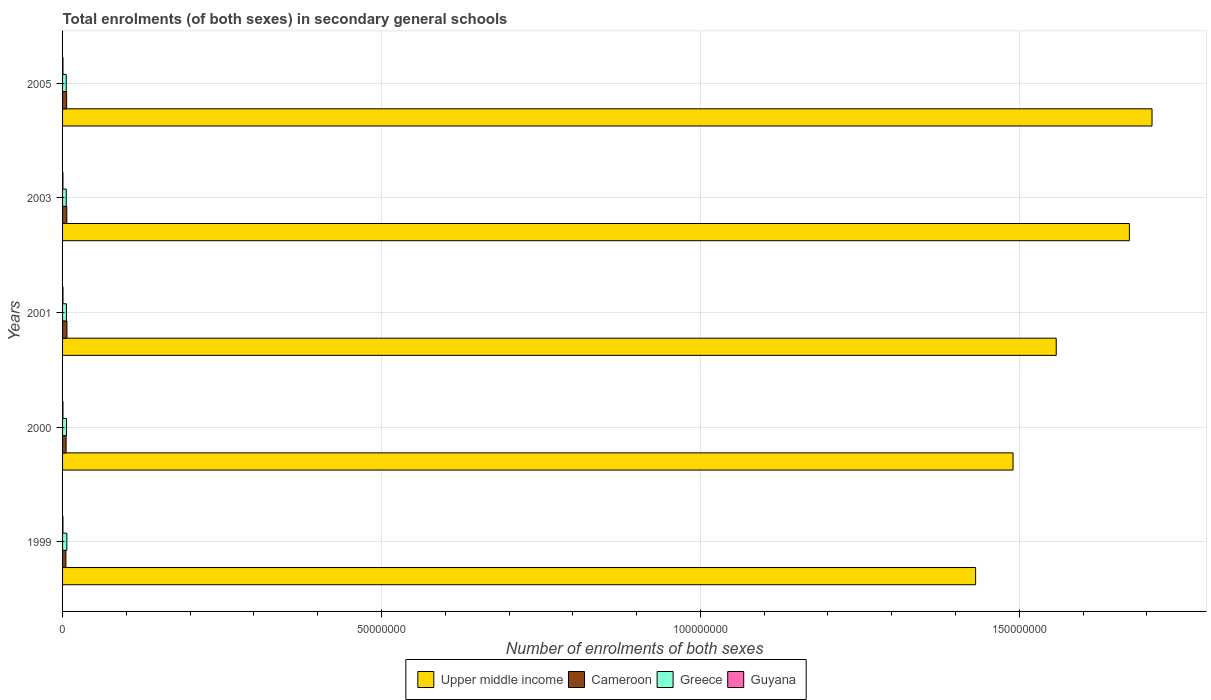How many groups of bars are there?
Keep it short and to the point. 5. Are the number of bars per tick equal to the number of legend labels?
Your response must be concise. Yes. In how many cases, is the number of bars for a given year not equal to the number of legend labels?
Keep it short and to the point. 0. What is the number of enrolments in secondary schools in Guyana in 1999?
Offer a terse response. 5.80e+04. Across all years, what is the maximum number of enrolments in secondary schools in Upper middle income?
Give a very brief answer. 1.71e+08. Across all years, what is the minimum number of enrolments in secondary schools in Guyana?
Your answer should be very brief. 5.80e+04. In which year was the number of enrolments in secondary schools in Cameroon maximum?
Offer a terse response. 2001. In which year was the number of enrolments in secondary schools in Cameroon minimum?
Your answer should be very brief. 1999. What is the total number of enrolments in secondary schools in Guyana in the graph?
Keep it short and to the point. 3.09e+05. What is the difference between the number of enrolments in secondary schools in Upper middle income in 2000 and that in 2001?
Provide a short and direct response. -6.77e+06. What is the difference between the number of enrolments in secondary schools in Greece in 2000 and the number of enrolments in secondary schools in Guyana in 2003?
Ensure brevity in your answer.  5.60e+05. What is the average number of enrolments in secondary schools in Upper middle income per year?
Ensure brevity in your answer.  1.57e+08. In the year 2000, what is the difference between the number of enrolments in secondary schools in Greece and number of enrolments in secondary schools in Upper middle income?
Keep it short and to the point. -1.48e+08. What is the ratio of the number of enrolments in secondary schools in Greece in 2000 to that in 2005?
Your response must be concise. 1.07. Is the difference between the number of enrolments in secondary schools in Greece in 2000 and 2001 greater than the difference between the number of enrolments in secondary schools in Upper middle income in 2000 and 2001?
Offer a very short reply. Yes. What is the difference between the highest and the second highest number of enrolments in secondary schools in Greece?
Your answer should be compact. 5.04e+04. What is the difference between the highest and the lowest number of enrolments in secondary schools in Cameroon?
Provide a succinct answer. 1.64e+05. In how many years, is the number of enrolments in secondary schools in Greece greater than the average number of enrolments in secondary schools in Greece taken over all years?
Offer a terse response. 2. Is the sum of the number of enrolments in secondary schools in Greece in 2001 and 2003 greater than the maximum number of enrolments in secondary schools in Cameroon across all years?
Provide a short and direct response. Yes. Is it the case that in every year, the sum of the number of enrolments in secondary schools in Greece and number of enrolments in secondary schools in Upper middle income is greater than the sum of number of enrolments in secondary schools in Cameroon and number of enrolments in secondary schools in Guyana?
Give a very brief answer. No. What does the 2nd bar from the top in 1999 represents?
Your answer should be compact. Greece. What does the 4th bar from the bottom in 2000 represents?
Ensure brevity in your answer.  Guyana. Is it the case that in every year, the sum of the number of enrolments in secondary schools in Upper middle income and number of enrolments in secondary schools in Cameroon is greater than the number of enrolments in secondary schools in Greece?
Offer a very short reply. Yes. How many years are there in the graph?
Make the answer very short. 5. Are the values on the major ticks of X-axis written in scientific E-notation?
Offer a terse response. No. Does the graph contain any zero values?
Offer a terse response. No. Where does the legend appear in the graph?
Your answer should be very brief. Bottom center. How many legend labels are there?
Offer a terse response. 4. What is the title of the graph?
Keep it short and to the point. Total enrolments (of both sexes) in secondary general schools. Does "Bahamas" appear as one of the legend labels in the graph?
Your response must be concise. No. What is the label or title of the X-axis?
Your answer should be very brief. Number of enrolments of both sexes. What is the label or title of the Y-axis?
Give a very brief answer. Years. What is the Number of enrolments of both sexes of Upper middle income in 1999?
Give a very brief answer. 1.43e+08. What is the Number of enrolments of both sexes in Cameroon in 1999?
Provide a succinct answer. 5.21e+05. What is the Number of enrolments of both sexes in Greece in 1999?
Offer a terse response. 6.70e+05. What is the Number of enrolments of both sexes in Guyana in 1999?
Your response must be concise. 5.80e+04. What is the Number of enrolments of both sexes of Upper middle income in 2000?
Your answer should be very brief. 1.49e+08. What is the Number of enrolments of both sexes of Cameroon in 2000?
Make the answer very short. 5.55e+05. What is the Number of enrolments of both sexes of Greece in 2000?
Provide a succinct answer. 6.19e+05. What is the Number of enrolments of both sexes of Guyana in 2000?
Offer a very short reply. 6.17e+04. What is the Number of enrolments of both sexes of Upper middle income in 2001?
Make the answer very short. 1.56e+08. What is the Number of enrolments of both sexes in Cameroon in 2001?
Provide a succinct answer. 6.85e+05. What is the Number of enrolments of both sexes of Greece in 2001?
Offer a very short reply. 6.09e+05. What is the Number of enrolments of both sexes of Guyana in 2001?
Offer a terse response. 6.58e+04. What is the Number of enrolments of both sexes in Upper middle income in 2003?
Give a very brief answer. 1.67e+08. What is the Number of enrolments of both sexes of Cameroon in 2003?
Your answer should be compact. 6.69e+05. What is the Number of enrolments of both sexes of Greece in 2003?
Offer a terse response. 5.80e+05. What is the Number of enrolments of both sexes of Guyana in 2003?
Give a very brief answer. 5.94e+04. What is the Number of enrolments of both sexes of Upper middle income in 2005?
Your answer should be compact. 1.71e+08. What is the Number of enrolments of both sexes of Cameroon in 2005?
Give a very brief answer. 6.40e+05. What is the Number of enrolments of both sexes of Greece in 2005?
Your response must be concise. 5.78e+05. What is the Number of enrolments of both sexes of Guyana in 2005?
Provide a short and direct response. 6.38e+04. Across all years, what is the maximum Number of enrolments of both sexes of Upper middle income?
Make the answer very short. 1.71e+08. Across all years, what is the maximum Number of enrolments of both sexes in Cameroon?
Provide a succinct answer. 6.85e+05. Across all years, what is the maximum Number of enrolments of both sexes of Greece?
Your answer should be very brief. 6.70e+05. Across all years, what is the maximum Number of enrolments of both sexes in Guyana?
Give a very brief answer. 6.58e+04. Across all years, what is the minimum Number of enrolments of both sexes in Upper middle income?
Offer a terse response. 1.43e+08. Across all years, what is the minimum Number of enrolments of both sexes in Cameroon?
Offer a terse response. 5.21e+05. Across all years, what is the minimum Number of enrolments of both sexes in Greece?
Provide a succinct answer. 5.78e+05. Across all years, what is the minimum Number of enrolments of both sexes of Guyana?
Keep it short and to the point. 5.80e+04. What is the total Number of enrolments of both sexes in Upper middle income in the graph?
Ensure brevity in your answer.  7.86e+08. What is the total Number of enrolments of both sexes of Cameroon in the graph?
Ensure brevity in your answer.  3.07e+06. What is the total Number of enrolments of both sexes of Greece in the graph?
Ensure brevity in your answer.  3.06e+06. What is the total Number of enrolments of both sexes in Guyana in the graph?
Your response must be concise. 3.09e+05. What is the difference between the Number of enrolments of both sexes of Upper middle income in 1999 and that in 2000?
Provide a short and direct response. -5.87e+06. What is the difference between the Number of enrolments of both sexes in Cameroon in 1999 and that in 2000?
Offer a very short reply. -3.42e+04. What is the difference between the Number of enrolments of both sexes in Greece in 1999 and that in 2000?
Your response must be concise. 5.04e+04. What is the difference between the Number of enrolments of both sexes of Guyana in 1999 and that in 2000?
Provide a succinct answer. -3670. What is the difference between the Number of enrolments of both sexes of Upper middle income in 1999 and that in 2001?
Provide a short and direct response. -1.26e+07. What is the difference between the Number of enrolments of both sexes in Cameroon in 1999 and that in 2001?
Provide a succinct answer. -1.64e+05. What is the difference between the Number of enrolments of both sexes of Greece in 1999 and that in 2001?
Provide a succinct answer. 6.06e+04. What is the difference between the Number of enrolments of both sexes of Guyana in 1999 and that in 2001?
Provide a succinct answer. -7793. What is the difference between the Number of enrolments of both sexes in Upper middle income in 1999 and that in 2003?
Offer a very short reply. -2.41e+07. What is the difference between the Number of enrolments of both sexes of Cameroon in 1999 and that in 2003?
Offer a terse response. -1.48e+05. What is the difference between the Number of enrolments of both sexes in Greece in 1999 and that in 2003?
Ensure brevity in your answer.  8.98e+04. What is the difference between the Number of enrolments of both sexes in Guyana in 1999 and that in 2003?
Your answer should be very brief. -1340. What is the difference between the Number of enrolments of both sexes in Upper middle income in 1999 and that in 2005?
Your answer should be compact. -2.77e+07. What is the difference between the Number of enrolments of both sexes of Cameroon in 1999 and that in 2005?
Offer a very short reply. -1.19e+05. What is the difference between the Number of enrolments of both sexes of Greece in 1999 and that in 2005?
Offer a terse response. 9.13e+04. What is the difference between the Number of enrolments of both sexes of Guyana in 1999 and that in 2005?
Offer a terse response. -5778. What is the difference between the Number of enrolments of both sexes in Upper middle income in 2000 and that in 2001?
Offer a terse response. -6.77e+06. What is the difference between the Number of enrolments of both sexes in Cameroon in 2000 and that in 2001?
Ensure brevity in your answer.  -1.30e+05. What is the difference between the Number of enrolments of both sexes in Greece in 2000 and that in 2001?
Keep it short and to the point. 1.02e+04. What is the difference between the Number of enrolments of both sexes of Guyana in 2000 and that in 2001?
Your answer should be compact. -4123. What is the difference between the Number of enrolments of both sexes in Upper middle income in 2000 and that in 2003?
Your answer should be very brief. -1.82e+07. What is the difference between the Number of enrolments of both sexes of Cameroon in 2000 and that in 2003?
Keep it short and to the point. -1.14e+05. What is the difference between the Number of enrolments of both sexes in Greece in 2000 and that in 2003?
Your response must be concise. 3.93e+04. What is the difference between the Number of enrolments of both sexes in Guyana in 2000 and that in 2003?
Provide a succinct answer. 2330. What is the difference between the Number of enrolments of both sexes in Upper middle income in 2000 and that in 2005?
Ensure brevity in your answer.  -2.18e+07. What is the difference between the Number of enrolments of both sexes of Cameroon in 2000 and that in 2005?
Offer a terse response. -8.53e+04. What is the difference between the Number of enrolments of both sexes in Greece in 2000 and that in 2005?
Provide a short and direct response. 4.09e+04. What is the difference between the Number of enrolments of both sexes of Guyana in 2000 and that in 2005?
Give a very brief answer. -2108. What is the difference between the Number of enrolments of both sexes in Upper middle income in 2001 and that in 2003?
Ensure brevity in your answer.  -1.15e+07. What is the difference between the Number of enrolments of both sexes of Cameroon in 2001 and that in 2003?
Your answer should be compact. 1.55e+04. What is the difference between the Number of enrolments of both sexes of Greece in 2001 and that in 2003?
Your response must be concise. 2.92e+04. What is the difference between the Number of enrolments of both sexes of Guyana in 2001 and that in 2003?
Your response must be concise. 6453. What is the difference between the Number of enrolments of both sexes of Upper middle income in 2001 and that in 2005?
Offer a terse response. -1.50e+07. What is the difference between the Number of enrolments of both sexes of Cameroon in 2001 and that in 2005?
Keep it short and to the point. 4.45e+04. What is the difference between the Number of enrolments of both sexes of Greece in 2001 and that in 2005?
Your answer should be compact. 3.07e+04. What is the difference between the Number of enrolments of both sexes in Guyana in 2001 and that in 2005?
Offer a very short reply. 2015. What is the difference between the Number of enrolments of both sexes of Upper middle income in 2003 and that in 2005?
Give a very brief answer. -3.55e+06. What is the difference between the Number of enrolments of both sexes of Cameroon in 2003 and that in 2005?
Offer a very short reply. 2.90e+04. What is the difference between the Number of enrolments of both sexes of Greece in 2003 and that in 2005?
Keep it short and to the point. 1548. What is the difference between the Number of enrolments of both sexes of Guyana in 2003 and that in 2005?
Offer a very short reply. -4438. What is the difference between the Number of enrolments of both sexes in Upper middle income in 1999 and the Number of enrolments of both sexes in Cameroon in 2000?
Offer a terse response. 1.43e+08. What is the difference between the Number of enrolments of both sexes in Upper middle income in 1999 and the Number of enrolments of both sexes in Greece in 2000?
Offer a very short reply. 1.43e+08. What is the difference between the Number of enrolments of both sexes in Upper middle income in 1999 and the Number of enrolments of both sexes in Guyana in 2000?
Provide a succinct answer. 1.43e+08. What is the difference between the Number of enrolments of both sexes of Cameroon in 1999 and the Number of enrolments of both sexes of Greece in 2000?
Make the answer very short. -9.84e+04. What is the difference between the Number of enrolments of both sexes of Cameroon in 1999 and the Number of enrolments of both sexes of Guyana in 2000?
Your answer should be compact. 4.59e+05. What is the difference between the Number of enrolments of both sexes in Greece in 1999 and the Number of enrolments of both sexes in Guyana in 2000?
Keep it short and to the point. 6.08e+05. What is the difference between the Number of enrolments of both sexes in Upper middle income in 1999 and the Number of enrolments of both sexes in Cameroon in 2001?
Offer a very short reply. 1.42e+08. What is the difference between the Number of enrolments of both sexes of Upper middle income in 1999 and the Number of enrolments of both sexes of Greece in 2001?
Your answer should be very brief. 1.43e+08. What is the difference between the Number of enrolments of both sexes in Upper middle income in 1999 and the Number of enrolments of both sexes in Guyana in 2001?
Offer a terse response. 1.43e+08. What is the difference between the Number of enrolments of both sexes in Cameroon in 1999 and the Number of enrolments of both sexes in Greece in 2001?
Your answer should be very brief. -8.83e+04. What is the difference between the Number of enrolments of both sexes in Cameroon in 1999 and the Number of enrolments of both sexes in Guyana in 2001?
Keep it short and to the point. 4.55e+05. What is the difference between the Number of enrolments of both sexes of Greece in 1999 and the Number of enrolments of both sexes of Guyana in 2001?
Give a very brief answer. 6.04e+05. What is the difference between the Number of enrolments of both sexes in Upper middle income in 1999 and the Number of enrolments of both sexes in Cameroon in 2003?
Give a very brief answer. 1.42e+08. What is the difference between the Number of enrolments of both sexes of Upper middle income in 1999 and the Number of enrolments of both sexes of Greece in 2003?
Offer a terse response. 1.43e+08. What is the difference between the Number of enrolments of both sexes in Upper middle income in 1999 and the Number of enrolments of both sexes in Guyana in 2003?
Your answer should be very brief. 1.43e+08. What is the difference between the Number of enrolments of both sexes in Cameroon in 1999 and the Number of enrolments of both sexes in Greece in 2003?
Offer a terse response. -5.91e+04. What is the difference between the Number of enrolments of both sexes in Cameroon in 1999 and the Number of enrolments of both sexes in Guyana in 2003?
Offer a terse response. 4.61e+05. What is the difference between the Number of enrolments of both sexes in Greece in 1999 and the Number of enrolments of both sexes in Guyana in 2003?
Your answer should be compact. 6.10e+05. What is the difference between the Number of enrolments of both sexes in Upper middle income in 1999 and the Number of enrolments of both sexes in Cameroon in 2005?
Offer a terse response. 1.43e+08. What is the difference between the Number of enrolments of both sexes in Upper middle income in 1999 and the Number of enrolments of both sexes in Greece in 2005?
Provide a short and direct response. 1.43e+08. What is the difference between the Number of enrolments of both sexes of Upper middle income in 1999 and the Number of enrolments of both sexes of Guyana in 2005?
Ensure brevity in your answer.  1.43e+08. What is the difference between the Number of enrolments of both sexes of Cameroon in 1999 and the Number of enrolments of both sexes of Greece in 2005?
Your answer should be compact. -5.75e+04. What is the difference between the Number of enrolments of both sexes in Cameroon in 1999 and the Number of enrolments of both sexes in Guyana in 2005?
Your response must be concise. 4.57e+05. What is the difference between the Number of enrolments of both sexes of Greece in 1999 and the Number of enrolments of both sexes of Guyana in 2005?
Offer a terse response. 6.06e+05. What is the difference between the Number of enrolments of both sexes of Upper middle income in 2000 and the Number of enrolments of both sexes of Cameroon in 2001?
Provide a short and direct response. 1.48e+08. What is the difference between the Number of enrolments of both sexes in Upper middle income in 2000 and the Number of enrolments of both sexes in Greece in 2001?
Ensure brevity in your answer.  1.48e+08. What is the difference between the Number of enrolments of both sexes in Upper middle income in 2000 and the Number of enrolments of both sexes in Guyana in 2001?
Provide a succinct answer. 1.49e+08. What is the difference between the Number of enrolments of both sexes of Cameroon in 2000 and the Number of enrolments of both sexes of Greece in 2001?
Provide a succinct answer. -5.41e+04. What is the difference between the Number of enrolments of both sexes of Cameroon in 2000 and the Number of enrolments of both sexes of Guyana in 2001?
Provide a short and direct response. 4.89e+05. What is the difference between the Number of enrolments of both sexes of Greece in 2000 and the Number of enrolments of both sexes of Guyana in 2001?
Offer a terse response. 5.53e+05. What is the difference between the Number of enrolments of both sexes in Upper middle income in 2000 and the Number of enrolments of both sexes in Cameroon in 2003?
Your answer should be very brief. 1.48e+08. What is the difference between the Number of enrolments of both sexes of Upper middle income in 2000 and the Number of enrolments of both sexes of Greece in 2003?
Your answer should be compact. 1.48e+08. What is the difference between the Number of enrolments of both sexes in Upper middle income in 2000 and the Number of enrolments of both sexes in Guyana in 2003?
Keep it short and to the point. 1.49e+08. What is the difference between the Number of enrolments of both sexes of Cameroon in 2000 and the Number of enrolments of both sexes of Greece in 2003?
Ensure brevity in your answer.  -2.49e+04. What is the difference between the Number of enrolments of both sexes of Cameroon in 2000 and the Number of enrolments of both sexes of Guyana in 2003?
Your response must be concise. 4.95e+05. What is the difference between the Number of enrolments of both sexes in Greece in 2000 and the Number of enrolments of both sexes in Guyana in 2003?
Your answer should be very brief. 5.60e+05. What is the difference between the Number of enrolments of both sexes in Upper middle income in 2000 and the Number of enrolments of both sexes in Cameroon in 2005?
Provide a short and direct response. 1.48e+08. What is the difference between the Number of enrolments of both sexes of Upper middle income in 2000 and the Number of enrolments of both sexes of Greece in 2005?
Offer a very short reply. 1.48e+08. What is the difference between the Number of enrolments of both sexes in Upper middle income in 2000 and the Number of enrolments of both sexes in Guyana in 2005?
Make the answer very short. 1.49e+08. What is the difference between the Number of enrolments of both sexes in Cameroon in 2000 and the Number of enrolments of both sexes in Greece in 2005?
Provide a succinct answer. -2.34e+04. What is the difference between the Number of enrolments of both sexes of Cameroon in 2000 and the Number of enrolments of both sexes of Guyana in 2005?
Ensure brevity in your answer.  4.91e+05. What is the difference between the Number of enrolments of both sexes of Greece in 2000 and the Number of enrolments of both sexes of Guyana in 2005?
Provide a short and direct response. 5.55e+05. What is the difference between the Number of enrolments of both sexes of Upper middle income in 2001 and the Number of enrolments of both sexes of Cameroon in 2003?
Ensure brevity in your answer.  1.55e+08. What is the difference between the Number of enrolments of both sexes in Upper middle income in 2001 and the Number of enrolments of both sexes in Greece in 2003?
Keep it short and to the point. 1.55e+08. What is the difference between the Number of enrolments of both sexes of Upper middle income in 2001 and the Number of enrolments of both sexes of Guyana in 2003?
Offer a terse response. 1.56e+08. What is the difference between the Number of enrolments of both sexes of Cameroon in 2001 and the Number of enrolments of both sexes of Greece in 2003?
Your response must be concise. 1.05e+05. What is the difference between the Number of enrolments of both sexes of Cameroon in 2001 and the Number of enrolments of both sexes of Guyana in 2003?
Offer a very short reply. 6.25e+05. What is the difference between the Number of enrolments of both sexes of Greece in 2001 and the Number of enrolments of both sexes of Guyana in 2003?
Give a very brief answer. 5.50e+05. What is the difference between the Number of enrolments of both sexes of Upper middle income in 2001 and the Number of enrolments of both sexes of Cameroon in 2005?
Provide a succinct answer. 1.55e+08. What is the difference between the Number of enrolments of both sexes in Upper middle income in 2001 and the Number of enrolments of both sexes in Greece in 2005?
Keep it short and to the point. 1.55e+08. What is the difference between the Number of enrolments of both sexes in Upper middle income in 2001 and the Number of enrolments of both sexes in Guyana in 2005?
Your answer should be compact. 1.56e+08. What is the difference between the Number of enrolments of both sexes of Cameroon in 2001 and the Number of enrolments of both sexes of Greece in 2005?
Your answer should be compact. 1.06e+05. What is the difference between the Number of enrolments of both sexes in Cameroon in 2001 and the Number of enrolments of both sexes in Guyana in 2005?
Offer a terse response. 6.21e+05. What is the difference between the Number of enrolments of both sexes in Greece in 2001 and the Number of enrolments of both sexes in Guyana in 2005?
Provide a succinct answer. 5.45e+05. What is the difference between the Number of enrolments of both sexes in Upper middle income in 2003 and the Number of enrolments of both sexes in Cameroon in 2005?
Keep it short and to the point. 1.67e+08. What is the difference between the Number of enrolments of both sexes of Upper middle income in 2003 and the Number of enrolments of both sexes of Greece in 2005?
Make the answer very short. 1.67e+08. What is the difference between the Number of enrolments of both sexes of Upper middle income in 2003 and the Number of enrolments of both sexes of Guyana in 2005?
Your answer should be compact. 1.67e+08. What is the difference between the Number of enrolments of both sexes in Cameroon in 2003 and the Number of enrolments of both sexes in Greece in 2005?
Provide a short and direct response. 9.09e+04. What is the difference between the Number of enrolments of both sexes of Cameroon in 2003 and the Number of enrolments of both sexes of Guyana in 2005?
Give a very brief answer. 6.05e+05. What is the difference between the Number of enrolments of both sexes of Greece in 2003 and the Number of enrolments of both sexes of Guyana in 2005?
Your answer should be compact. 5.16e+05. What is the average Number of enrolments of both sexes of Upper middle income per year?
Provide a short and direct response. 1.57e+08. What is the average Number of enrolments of both sexes in Cameroon per year?
Your response must be concise. 6.14e+05. What is the average Number of enrolments of both sexes in Greece per year?
Make the answer very short. 6.11e+05. What is the average Number of enrolments of both sexes in Guyana per year?
Provide a short and direct response. 6.17e+04. In the year 1999, what is the difference between the Number of enrolments of both sexes of Upper middle income and Number of enrolments of both sexes of Cameroon?
Ensure brevity in your answer.  1.43e+08. In the year 1999, what is the difference between the Number of enrolments of both sexes in Upper middle income and Number of enrolments of both sexes in Greece?
Your answer should be very brief. 1.42e+08. In the year 1999, what is the difference between the Number of enrolments of both sexes in Upper middle income and Number of enrolments of both sexes in Guyana?
Offer a terse response. 1.43e+08. In the year 1999, what is the difference between the Number of enrolments of both sexes of Cameroon and Number of enrolments of both sexes of Greece?
Your answer should be very brief. -1.49e+05. In the year 1999, what is the difference between the Number of enrolments of both sexes in Cameroon and Number of enrolments of both sexes in Guyana?
Provide a succinct answer. 4.63e+05. In the year 1999, what is the difference between the Number of enrolments of both sexes in Greece and Number of enrolments of both sexes in Guyana?
Your answer should be very brief. 6.11e+05. In the year 2000, what is the difference between the Number of enrolments of both sexes in Upper middle income and Number of enrolments of both sexes in Cameroon?
Provide a short and direct response. 1.48e+08. In the year 2000, what is the difference between the Number of enrolments of both sexes in Upper middle income and Number of enrolments of both sexes in Greece?
Provide a succinct answer. 1.48e+08. In the year 2000, what is the difference between the Number of enrolments of both sexes of Upper middle income and Number of enrolments of both sexes of Guyana?
Ensure brevity in your answer.  1.49e+08. In the year 2000, what is the difference between the Number of enrolments of both sexes in Cameroon and Number of enrolments of both sexes in Greece?
Your answer should be very brief. -6.43e+04. In the year 2000, what is the difference between the Number of enrolments of both sexes in Cameroon and Number of enrolments of both sexes in Guyana?
Offer a terse response. 4.93e+05. In the year 2000, what is the difference between the Number of enrolments of both sexes in Greece and Number of enrolments of both sexes in Guyana?
Provide a short and direct response. 5.57e+05. In the year 2001, what is the difference between the Number of enrolments of both sexes in Upper middle income and Number of enrolments of both sexes in Cameroon?
Your answer should be very brief. 1.55e+08. In the year 2001, what is the difference between the Number of enrolments of both sexes in Upper middle income and Number of enrolments of both sexes in Greece?
Provide a short and direct response. 1.55e+08. In the year 2001, what is the difference between the Number of enrolments of both sexes of Upper middle income and Number of enrolments of both sexes of Guyana?
Keep it short and to the point. 1.56e+08. In the year 2001, what is the difference between the Number of enrolments of both sexes of Cameroon and Number of enrolments of both sexes of Greece?
Keep it short and to the point. 7.57e+04. In the year 2001, what is the difference between the Number of enrolments of both sexes in Cameroon and Number of enrolments of both sexes in Guyana?
Make the answer very short. 6.19e+05. In the year 2001, what is the difference between the Number of enrolments of both sexes of Greece and Number of enrolments of both sexes of Guyana?
Give a very brief answer. 5.43e+05. In the year 2003, what is the difference between the Number of enrolments of both sexes in Upper middle income and Number of enrolments of both sexes in Cameroon?
Offer a terse response. 1.67e+08. In the year 2003, what is the difference between the Number of enrolments of both sexes in Upper middle income and Number of enrolments of both sexes in Greece?
Give a very brief answer. 1.67e+08. In the year 2003, what is the difference between the Number of enrolments of both sexes of Upper middle income and Number of enrolments of both sexes of Guyana?
Offer a very short reply. 1.67e+08. In the year 2003, what is the difference between the Number of enrolments of both sexes of Cameroon and Number of enrolments of both sexes of Greece?
Make the answer very short. 8.94e+04. In the year 2003, what is the difference between the Number of enrolments of both sexes of Cameroon and Number of enrolments of both sexes of Guyana?
Provide a short and direct response. 6.10e+05. In the year 2003, what is the difference between the Number of enrolments of both sexes of Greece and Number of enrolments of both sexes of Guyana?
Offer a very short reply. 5.20e+05. In the year 2005, what is the difference between the Number of enrolments of both sexes of Upper middle income and Number of enrolments of both sexes of Cameroon?
Offer a very short reply. 1.70e+08. In the year 2005, what is the difference between the Number of enrolments of both sexes of Upper middle income and Number of enrolments of both sexes of Greece?
Your answer should be very brief. 1.70e+08. In the year 2005, what is the difference between the Number of enrolments of both sexes of Upper middle income and Number of enrolments of both sexes of Guyana?
Your answer should be very brief. 1.71e+08. In the year 2005, what is the difference between the Number of enrolments of both sexes of Cameroon and Number of enrolments of both sexes of Greece?
Your answer should be very brief. 6.19e+04. In the year 2005, what is the difference between the Number of enrolments of both sexes in Cameroon and Number of enrolments of both sexes in Guyana?
Ensure brevity in your answer.  5.76e+05. In the year 2005, what is the difference between the Number of enrolments of both sexes of Greece and Number of enrolments of both sexes of Guyana?
Ensure brevity in your answer.  5.14e+05. What is the ratio of the Number of enrolments of both sexes in Upper middle income in 1999 to that in 2000?
Ensure brevity in your answer.  0.96. What is the ratio of the Number of enrolments of both sexes in Cameroon in 1999 to that in 2000?
Provide a short and direct response. 0.94. What is the ratio of the Number of enrolments of both sexes in Greece in 1999 to that in 2000?
Your answer should be compact. 1.08. What is the ratio of the Number of enrolments of both sexes in Guyana in 1999 to that in 2000?
Offer a very short reply. 0.94. What is the ratio of the Number of enrolments of both sexes in Upper middle income in 1999 to that in 2001?
Offer a terse response. 0.92. What is the ratio of the Number of enrolments of both sexes in Cameroon in 1999 to that in 2001?
Your response must be concise. 0.76. What is the ratio of the Number of enrolments of both sexes in Greece in 1999 to that in 2001?
Give a very brief answer. 1.1. What is the ratio of the Number of enrolments of both sexes of Guyana in 1999 to that in 2001?
Give a very brief answer. 0.88. What is the ratio of the Number of enrolments of both sexes in Upper middle income in 1999 to that in 2003?
Make the answer very short. 0.86. What is the ratio of the Number of enrolments of both sexes of Cameroon in 1999 to that in 2003?
Your answer should be compact. 0.78. What is the ratio of the Number of enrolments of both sexes of Greece in 1999 to that in 2003?
Offer a terse response. 1.15. What is the ratio of the Number of enrolments of both sexes of Guyana in 1999 to that in 2003?
Provide a short and direct response. 0.98. What is the ratio of the Number of enrolments of both sexes of Upper middle income in 1999 to that in 2005?
Ensure brevity in your answer.  0.84. What is the ratio of the Number of enrolments of both sexes in Cameroon in 1999 to that in 2005?
Provide a short and direct response. 0.81. What is the ratio of the Number of enrolments of both sexes in Greece in 1999 to that in 2005?
Give a very brief answer. 1.16. What is the ratio of the Number of enrolments of both sexes of Guyana in 1999 to that in 2005?
Provide a succinct answer. 0.91. What is the ratio of the Number of enrolments of both sexes in Upper middle income in 2000 to that in 2001?
Keep it short and to the point. 0.96. What is the ratio of the Number of enrolments of both sexes in Cameroon in 2000 to that in 2001?
Your answer should be very brief. 0.81. What is the ratio of the Number of enrolments of both sexes of Greece in 2000 to that in 2001?
Offer a terse response. 1.02. What is the ratio of the Number of enrolments of both sexes in Guyana in 2000 to that in 2001?
Ensure brevity in your answer.  0.94. What is the ratio of the Number of enrolments of both sexes in Upper middle income in 2000 to that in 2003?
Keep it short and to the point. 0.89. What is the ratio of the Number of enrolments of both sexes of Cameroon in 2000 to that in 2003?
Offer a very short reply. 0.83. What is the ratio of the Number of enrolments of both sexes of Greece in 2000 to that in 2003?
Provide a short and direct response. 1.07. What is the ratio of the Number of enrolments of both sexes of Guyana in 2000 to that in 2003?
Make the answer very short. 1.04. What is the ratio of the Number of enrolments of both sexes of Upper middle income in 2000 to that in 2005?
Offer a terse response. 0.87. What is the ratio of the Number of enrolments of both sexes of Cameroon in 2000 to that in 2005?
Keep it short and to the point. 0.87. What is the ratio of the Number of enrolments of both sexes of Greece in 2000 to that in 2005?
Provide a succinct answer. 1.07. What is the ratio of the Number of enrolments of both sexes in Upper middle income in 2001 to that in 2003?
Offer a very short reply. 0.93. What is the ratio of the Number of enrolments of both sexes in Cameroon in 2001 to that in 2003?
Your response must be concise. 1.02. What is the ratio of the Number of enrolments of both sexes of Greece in 2001 to that in 2003?
Offer a terse response. 1.05. What is the ratio of the Number of enrolments of both sexes in Guyana in 2001 to that in 2003?
Your response must be concise. 1.11. What is the ratio of the Number of enrolments of both sexes of Upper middle income in 2001 to that in 2005?
Ensure brevity in your answer.  0.91. What is the ratio of the Number of enrolments of both sexes of Cameroon in 2001 to that in 2005?
Your answer should be very brief. 1.07. What is the ratio of the Number of enrolments of both sexes of Greece in 2001 to that in 2005?
Provide a short and direct response. 1.05. What is the ratio of the Number of enrolments of both sexes of Guyana in 2001 to that in 2005?
Your response must be concise. 1.03. What is the ratio of the Number of enrolments of both sexes in Upper middle income in 2003 to that in 2005?
Your answer should be compact. 0.98. What is the ratio of the Number of enrolments of both sexes of Cameroon in 2003 to that in 2005?
Ensure brevity in your answer.  1.05. What is the ratio of the Number of enrolments of both sexes in Guyana in 2003 to that in 2005?
Offer a very short reply. 0.93. What is the difference between the highest and the second highest Number of enrolments of both sexes in Upper middle income?
Provide a short and direct response. 3.55e+06. What is the difference between the highest and the second highest Number of enrolments of both sexes of Cameroon?
Provide a short and direct response. 1.55e+04. What is the difference between the highest and the second highest Number of enrolments of both sexes in Greece?
Provide a short and direct response. 5.04e+04. What is the difference between the highest and the second highest Number of enrolments of both sexes in Guyana?
Your answer should be compact. 2015. What is the difference between the highest and the lowest Number of enrolments of both sexes of Upper middle income?
Keep it short and to the point. 2.77e+07. What is the difference between the highest and the lowest Number of enrolments of both sexes in Cameroon?
Your answer should be compact. 1.64e+05. What is the difference between the highest and the lowest Number of enrolments of both sexes in Greece?
Provide a succinct answer. 9.13e+04. What is the difference between the highest and the lowest Number of enrolments of both sexes in Guyana?
Provide a short and direct response. 7793. 